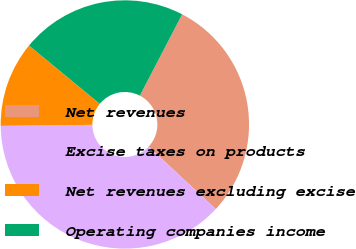<chart> <loc_0><loc_0><loc_500><loc_500><pie_chart><fcel>Net revenues<fcel>Excise taxes on products<fcel>Net revenues excluding excise<fcel>Operating companies income<nl><fcel>29.3%<fcel>37.9%<fcel>11.15%<fcel>21.66%<nl></chart> 